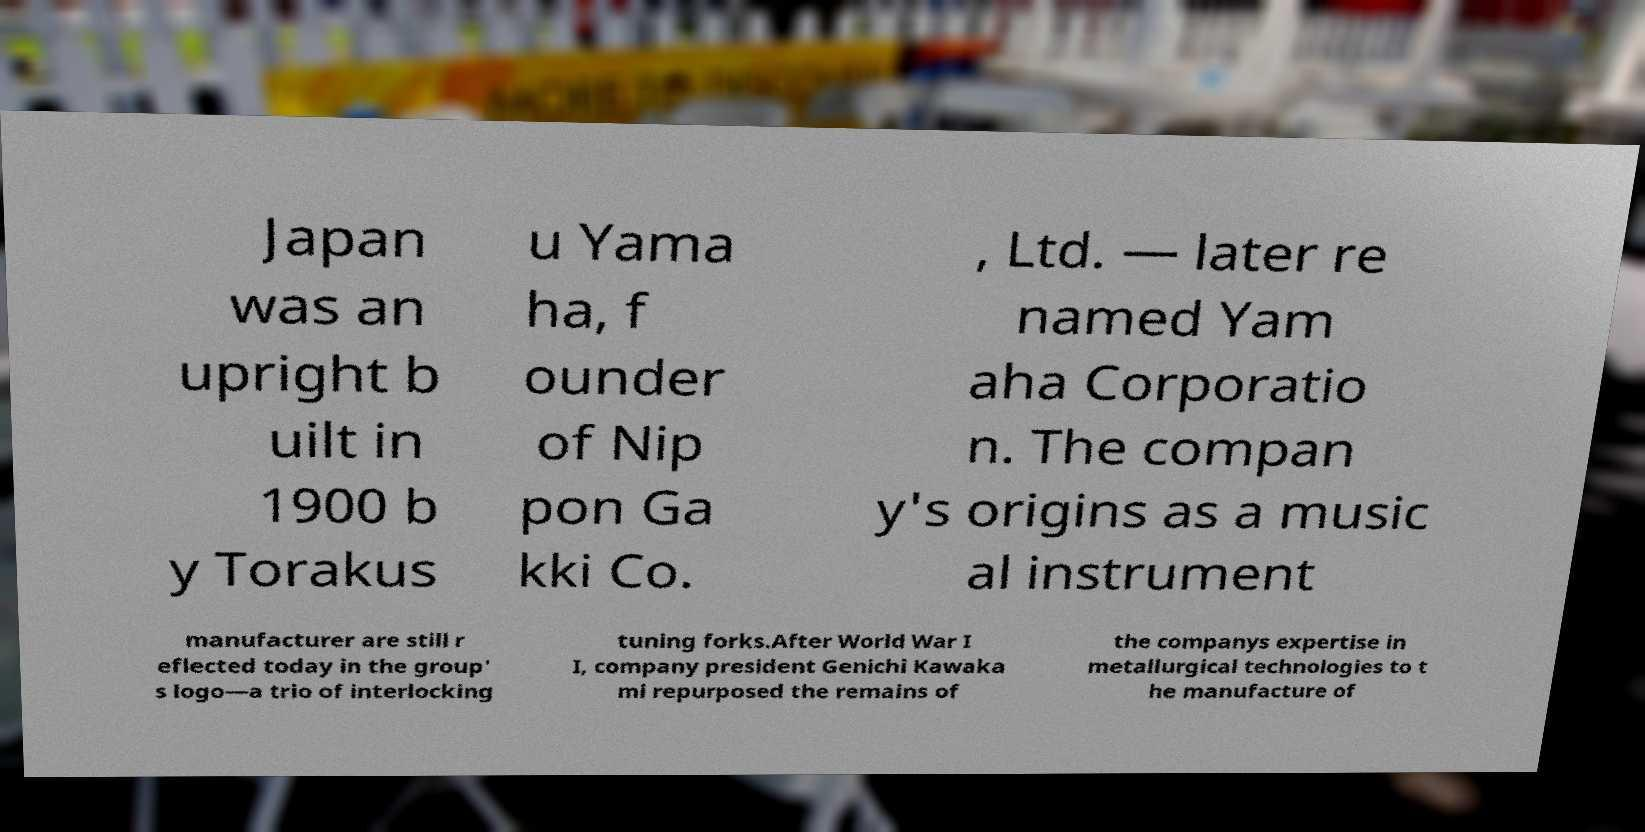Please read and relay the text visible in this image. What does it say? Japan was an upright b uilt in 1900 b y Torakus u Yama ha, f ounder of Nip pon Ga kki Co. , Ltd. — later re named Yam aha Corporatio n. The compan y's origins as a music al instrument manufacturer are still r eflected today in the group' s logo—a trio of interlocking tuning forks.After World War I I, company president Genichi Kawaka mi repurposed the remains of the companys expertise in metallurgical technologies to t he manufacture of 